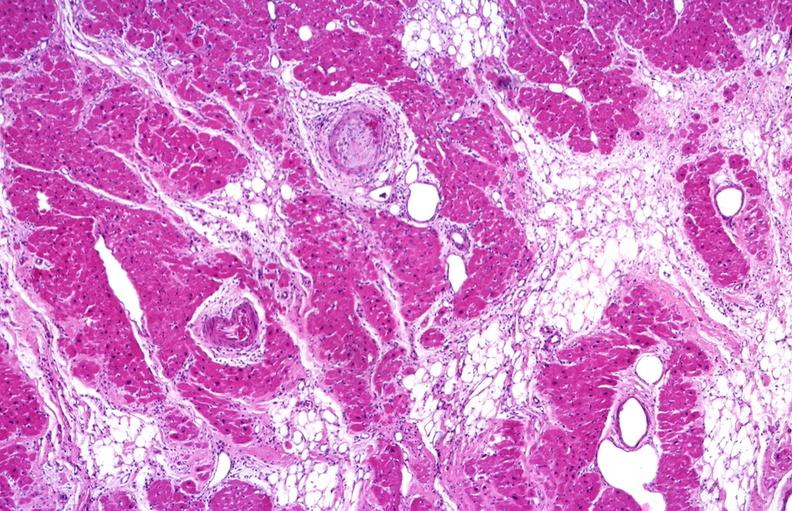what does this image show?
Answer the question using a single word or phrase. Heart 